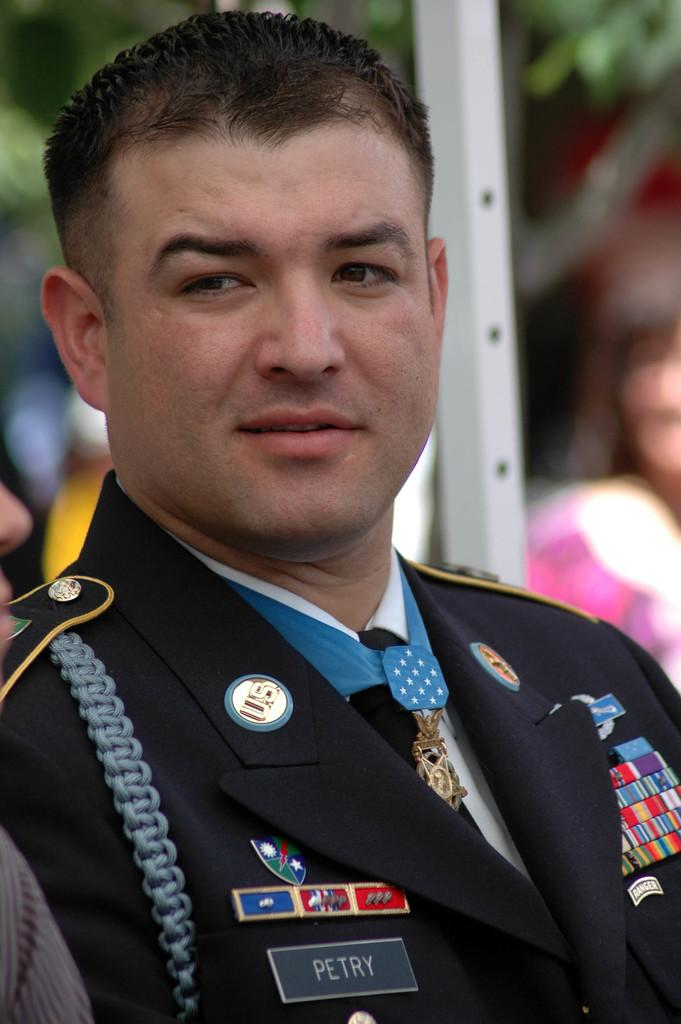Who is the main subject in the front of the image? There is a man in the front of the image. What part of another person can be seen on the left side of the image? There is a nose of another person on the left side of the image. What type of vegetation is visible in the background of the image? Leaves of a tree are visible in the background of the image. How would you describe the clarity of the background in the image? The background appears blurry. What type of bottle is being used to extend the range of the end of the tree in the image? There is no bottle, extension, or range mentioned in the image; it only features a man, a nose, leaves of a tree, and a blurry background. 